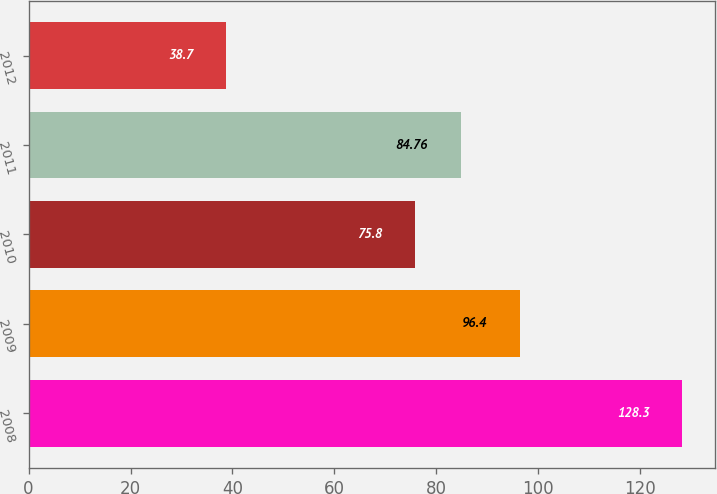Convert chart to OTSL. <chart><loc_0><loc_0><loc_500><loc_500><bar_chart><fcel>2008<fcel>2009<fcel>2010<fcel>2011<fcel>2012<nl><fcel>128.3<fcel>96.4<fcel>75.8<fcel>84.76<fcel>38.7<nl></chart> 